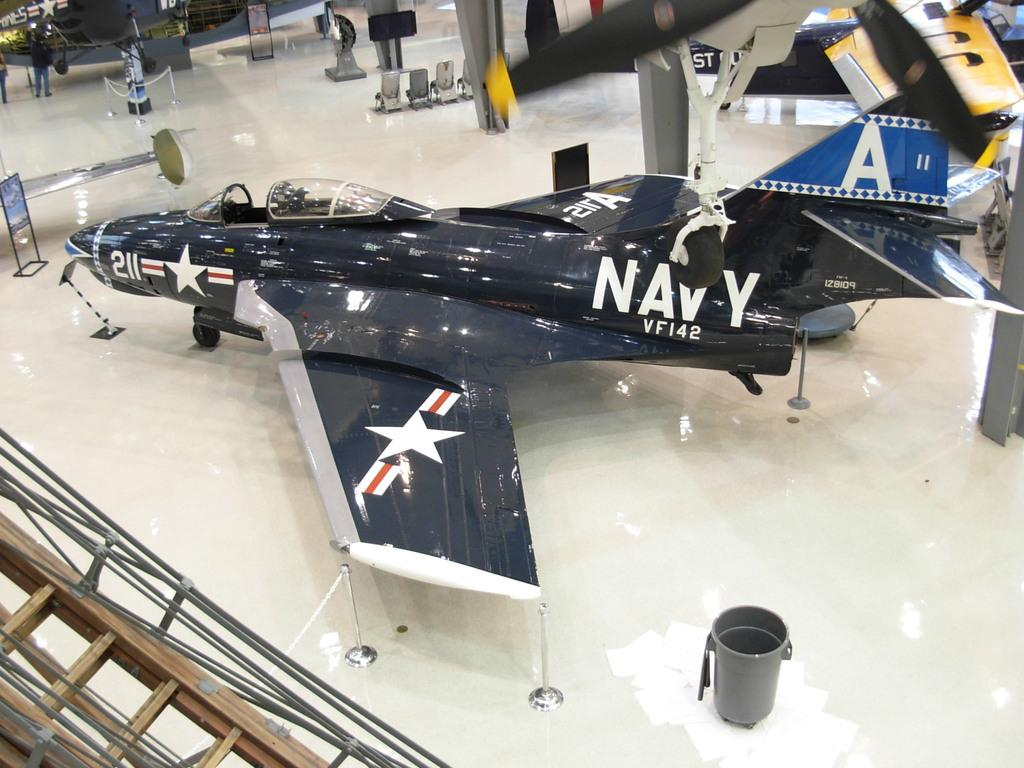<image>
Share a concise interpretation of the image provided. an image of a jet with the words NAVY VF142 on it. 